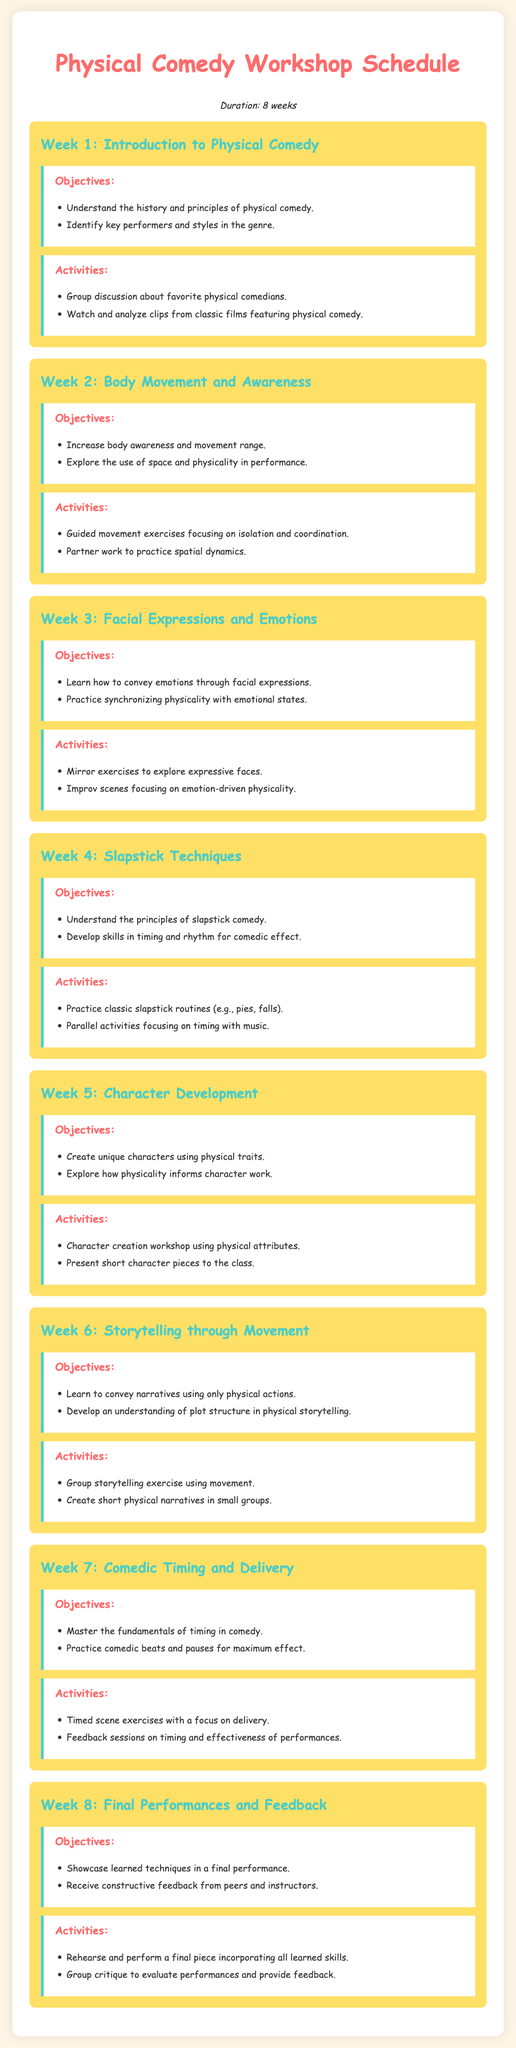What is the duration of the workshop? The document states that the workshop lasts for 8 weeks.
Answer: 8 weeks What is the main objective of Week 3? This week focuses on conveying emotions through facial expressions and synchronizing physicality with emotional states.
Answer: Convey emotions What activity is planned for Week 5? In Week 5, participants will present short character pieces to the class.
Answer: Character piece presentations What color is used for the headings in the document? The headings are styled in a shade of pink identified in the CSS as #FF6B6B.
Answer: Pink Which week covers slapstick techniques? This topic is addressed in Week 4 of the workshop schedule.
Answer: Week 4 What is the focus of the final performance in Week 8? The final performance aims to showcase the learned techniques from the course.
Answer: Showcase techniques How many objectives are listed for Week 2? There are two objectives specified for Week 2 regarding body movement and awareness.
Answer: Two objectives What type of exercises are included in Week 6? Week 6 includes group storytelling exercises using movement.
Answer: Storytelling exercises Who provides the feedback during the final performance? Feedback is provided by peers and instructors during the final performance.
Answer: Peers and instructors 